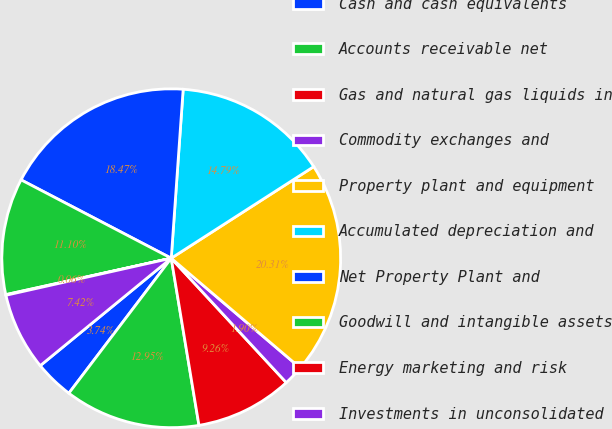Convert chart to OTSL. <chart><loc_0><loc_0><loc_500><loc_500><pie_chart><fcel>Cash and cash equivalents<fcel>Accounts receivable net<fcel>Gas and natural gas liquids in<fcel>Commodity exchanges and<fcel>Property plant and equipment<fcel>Accumulated depreciation and<fcel>Net Property Plant and<fcel>Goodwill and intangible assets<fcel>Energy marketing and risk<fcel>Investments in unconsolidated<nl><fcel>3.74%<fcel>12.94%<fcel>9.26%<fcel>1.9%<fcel>20.3%<fcel>14.78%<fcel>18.46%<fcel>11.1%<fcel>0.06%<fcel>7.42%<nl></chart> 